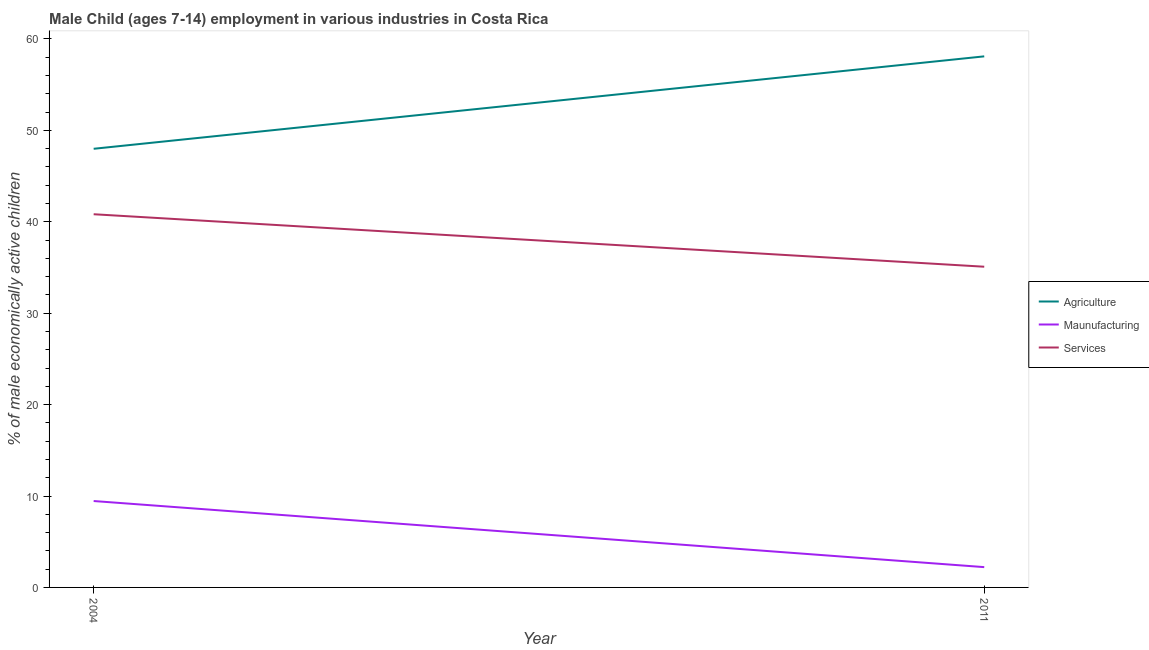Does the line corresponding to percentage of economically active children in agriculture intersect with the line corresponding to percentage of economically active children in services?
Offer a terse response. No. Is the number of lines equal to the number of legend labels?
Offer a terse response. Yes. What is the percentage of economically active children in agriculture in 2011?
Give a very brief answer. 58.09. Across all years, what is the maximum percentage of economically active children in manufacturing?
Keep it short and to the point. 9.45. Across all years, what is the minimum percentage of economically active children in manufacturing?
Offer a very short reply. 2.22. In which year was the percentage of economically active children in agriculture maximum?
Keep it short and to the point. 2011. In which year was the percentage of economically active children in services minimum?
Your answer should be very brief. 2011. What is the total percentage of economically active children in manufacturing in the graph?
Provide a short and direct response. 11.67. What is the difference between the percentage of economically active children in services in 2004 and that in 2011?
Your answer should be compact. 5.74. What is the difference between the percentage of economically active children in manufacturing in 2011 and the percentage of economically active children in agriculture in 2004?
Keep it short and to the point. -45.76. What is the average percentage of economically active children in services per year?
Ensure brevity in your answer.  37.95. In the year 2004, what is the difference between the percentage of economically active children in agriculture and percentage of economically active children in services?
Keep it short and to the point. 7.16. In how many years, is the percentage of economically active children in agriculture greater than 10 %?
Provide a short and direct response. 2. What is the ratio of the percentage of economically active children in manufacturing in 2004 to that in 2011?
Offer a terse response. 4.26. Is the percentage of economically active children in manufacturing in 2004 less than that in 2011?
Your answer should be compact. No. Is it the case that in every year, the sum of the percentage of economically active children in agriculture and percentage of economically active children in manufacturing is greater than the percentage of economically active children in services?
Keep it short and to the point. Yes. Does the percentage of economically active children in agriculture monotonically increase over the years?
Your answer should be compact. Yes. Is the percentage of economically active children in agriculture strictly greater than the percentage of economically active children in manufacturing over the years?
Your answer should be compact. Yes. Is the percentage of economically active children in services strictly less than the percentage of economically active children in agriculture over the years?
Your response must be concise. Yes. How many lines are there?
Keep it short and to the point. 3. How many years are there in the graph?
Provide a short and direct response. 2. What is the difference between two consecutive major ticks on the Y-axis?
Your answer should be compact. 10. How many legend labels are there?
Make the answer very short. 3. How are the legend labels stacked?
Offer a terse response. Vertical. What is the title of the graph?
Offer a terse response. Male Child (ages 7-14) employment in various industries in Costa Rica. What is the label or title of the X-axis?
Your response must be concise. Year. What is the label or title of the Y-axis?
Your response must be concise. % of male economically active children. What is the % of male economically active children of Agriculture in 2004?
Provide a short and direct response. 47.98. What is the % of male economically active children of Maunufacturing in 2004?
Provide a succinct answer. 9.45. What is the % of male economically active children of Services in 2004?
Offer a terse response. 40.82. What is the % of male economically active children of Agriculture in 2011?
Your answer should be compact. 58.09. What is the % of male economically active children in Maunufacturing in 2011?
Offer a very short reply. 2.22. What is the % of male economically active children of Services in 2011?
Offer a very short reply. 35.08. Across all years, what is the maximum % of male economically active children in Agriculture?
Offer a very short reply. 58.09. Across all years, what is the maximum % of male economically active children of Maunufacturing?
Your answer should be very brief. 9.45. Across all years, what is the maximum % of male economically active children of Services?
Provide a short and direct response. 40.82. Across all years, what is the minimum % of male economically active children of Agriculture?
Your answer should be compact. 47.98. Across all years, what is the minimum % of male economically active children of Maunufacturing?
Provide a succinct answer. 2.22. Across all years, what is the minimum % of male economically active children in Services?
Your answer should be very brief. 35.08. What is the total % of male economically active children of Agriculture in the graph?
Your answer should be very brief. 106.07. What is the total % of male economically active children of Maunufacturing in the graph?
Give a very brief answer. 11.67. What is the total % of male economically active children of Services in the graph?
Ensure brevity in your answer.  75.9. What is the difference between the % of male economically active children in Agriculture in 2004 and that in 2011?
Provide a succinct answer. -10.11. What is the difference between the % of male economically active children of Maunufacturing in 2004 and that in 2011?
Offer a very short reply. 7.23. What is the difference between the % of male economically active children in Services in 2004 and that in 2011?
Offer a terse response. 5.74. What is the difference between the % of male economically active children in Agriculture in 2004 and the % of male economically active children in Maunufacturing in 2011?
Provide a succinct answer. 45.76. What is the difference between the % of male economically active children of Maunufacturing in 2004 and the % of male economically active children of Services in 2011?
Your answer should be very brief. -25.63. What is the average % of male economically active children in Agriculture per year?
Provide a succinct answer. 53.03. What is the average % of male economically active children of Maunufacturing per year?
Provide a short and direct response. 5.83. What is the average % of male economically active children of Services per year?
Ensure brevity in your answer.  37.95. In the year 2004, what is the difference between the % of male economically active children in Agriculture and % of male economically active children in Maunufacturing?
Offer a very short reply. 38.53. In the year 2004, what is the difference between the % of male economically active children in Agriculture and % of male economically active children in Services?
Your answer should be compact. 7.16. In the year 2004, what is the difference between the % of male economically active children of Maunufacturing and % of male economically active children of Services?
Your answer should be very brief. -31.37. In the year 2011, what is the difference between the % of male economically active children in Agriculture and % of male economically active children in Maunufacturing?
Offer a very short reply. 55.87. In the year 2011, what is the difference between the % of male economically active children in Agriculture and % of male economically active children in Services?
Offer a very short reply. 23.01. In the year 2011, what is the difference between the % of male economically active children in Maunufacturing and % of male economically active children in Services?
Give a very brief answer. -32.86. What is the ratio of the % of male economically active children of Agriculture in 2004 to that in 2011?
Keep it short and to the point. 0.83. What is the ratio of the % of male economically active children of Maunufacturing in 2004 to that in 2011?
Offer a terse response. 4.26. What is the ratio of the % of male economically active children in Services in 2004 to that in 2011?
Your answer should be very brief. 1.16. What is the difference between the highest and the second highest % of male economically active children in Agriculture?
Ensure brevity in your answer.  10.11. What is the difference between the highest and the second highest % of male economically active children in Maunufacturing?
Your answer should be compact. 7.23. What is the difference between the highest and the second highest % of male economically active children of Services?
Keep it short and to the point. 5.74. What is the difference between the highest and the lowest % of male economically active children in Agriculture?
Offer a very short reply. 10.11. What is the difference between the highest and the lowest % of male economically active children of Maunufacturing?
Offer a very short reply. 7.23. What is the difference between the highest and the lowest % of male economically active children of Services?
Provide a succinct answer. 5.74. 